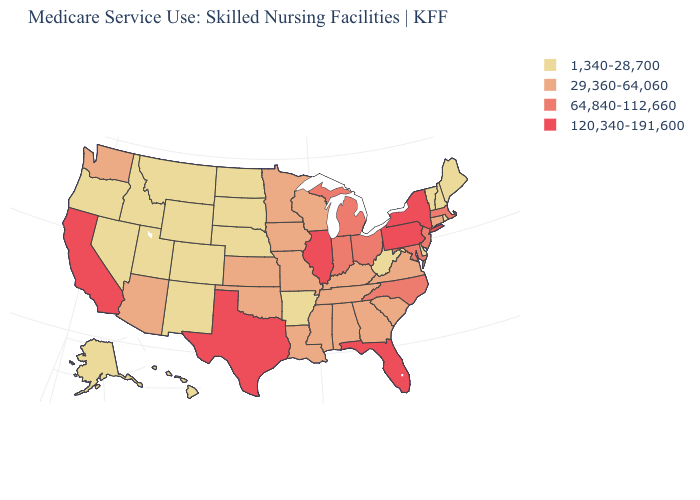Does West Virginia have a higher value than Kansas?
Short answer required. No. Name the states that have a value in the range 1,340-28,700?
Keep it brief. Alaska, Arkansas, Colorado, Delaware, Hawaii, Idaho, Maine, Montana, Nebraska, Nevada, New Hampshire, New Mexico, North Dakota, Oregon, Rhode Island, South Dakota, Utah, Vermont, West Virginia, Wyoming. Name the states that have a value in the range 29,360-64,060?
Write a very short answer. Alabama, Arizona, Connecticut, Georgia, Iowa, Kansas, Kentucky, Louisiana, Minnesota, Mississippi, Missouri, Oklahoma, South Carolina, Tennessee, Virginia, Washington, Wisconsin. Among the states that border Maine , which have the lowest value?
Answer briefly. New Hampshire. What is the value of Hawaii?
Give a very brief answer. 1,340-28,700. Among the states that border Louisiana , does Arkansas have the lowest value?
Concise answer only. Yes. What is the value of South Dakota?
Short answer required. 1,340-28,700. Among the states that border Missouri , which have the highest value?
Write a very short answer. Illinois. Does the map have missing data?
Be succinct. No. Does Indiana have the same value as New Jersey?
Write a very short answer. Yes. Does Texas have the highest value in the USA?
Write a very short answer. Yes. Is the legend a continuous bar?
Keep it brief. No. Does the first symbol in the legend represent the smallest category?
Give a very brief answer. Yes. Does Alaska have a lower value than South Dakota?
Short answer required. No. Is the legend a continuous bar?
Answer briefly. No. 